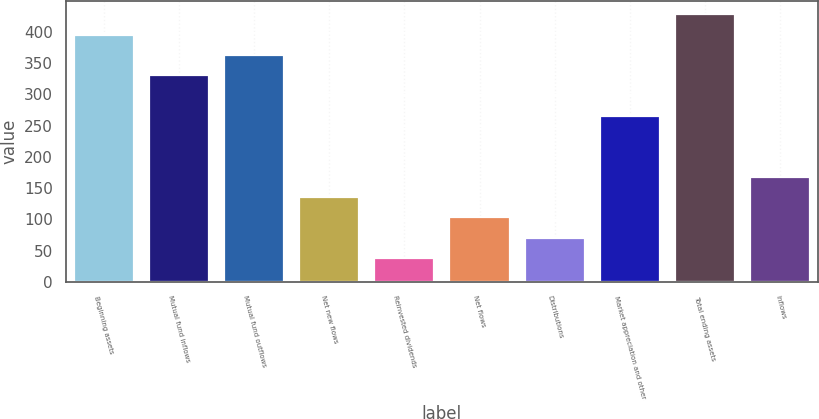Convert chart to OTSL. <chart><loc_0><loc_0><loc_500><loc_500><bar_chart><fcel>Beginning assets<fcel>Mutual fund inflows<fcel>Mutual fund outflows<fcel>Net new flows<fcel>Reinvested dividends<fcel>Net flows<fcel>Distributions<fcel>Market appreciation and other<fcel>Total ending assets<fcel>Inflows<nl><fcel>395.36<fcel>330.4<fcel>362.88<fcel>135.52<fcel>38.08<fcel>103.04<fcel>70.56<fcel>265.44<fcel>427.84<fcel>168<nl></chart> 